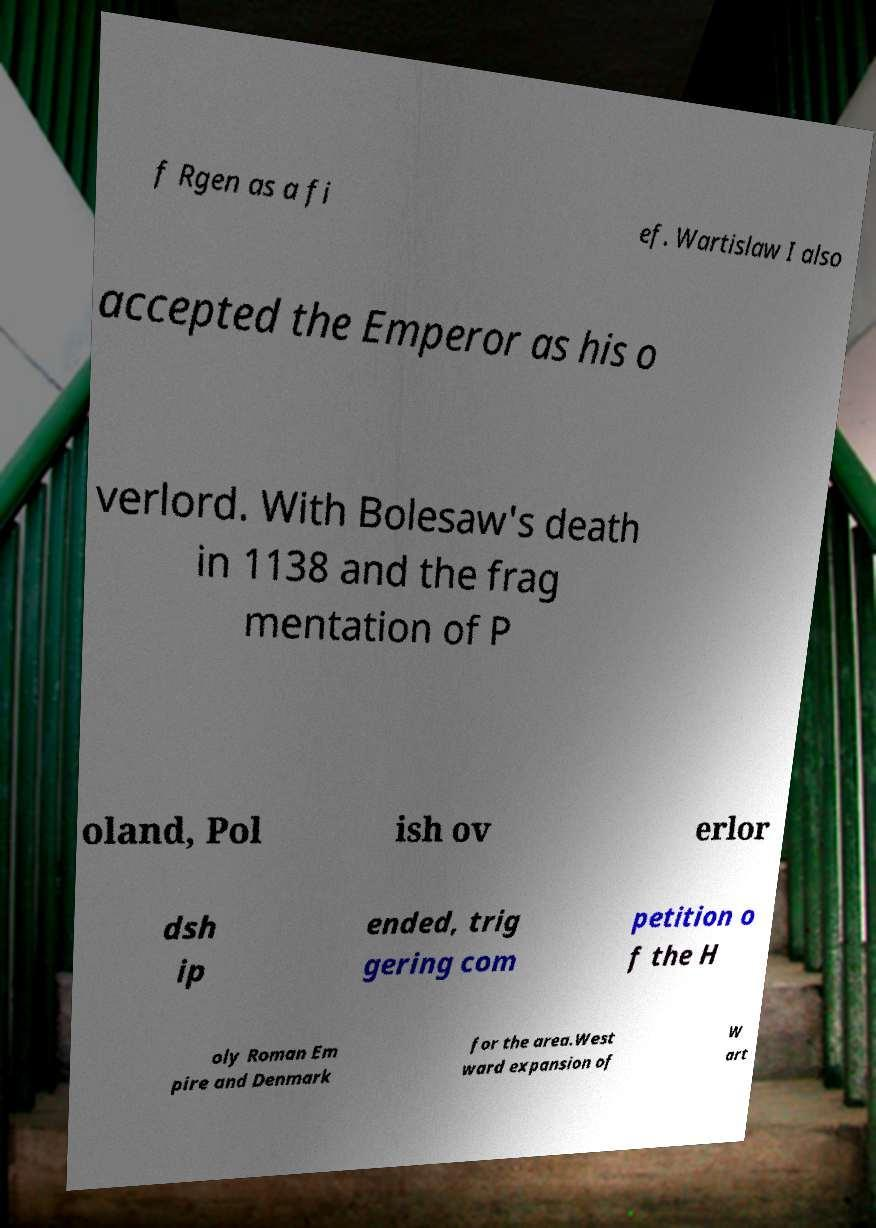Can you accurately transcribe the text from the provided image for me? f Rgen as a fi ef. Wartislaw I also accepted the Emperor as his o verlord. With Bolesaw's death in 1138 and the frag mentation of P oland, Pol ish ov erlor dsh ip ended, trig gering com petition o f the H oly Roman Em pire and Denmark for the area.West ward expansion of W art 